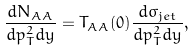Convert formula to latex. <formula><loc_0><loc_0><loc_500><loc_500>\frac { d N _ { A A } } { d p _ { T } ^ { 2 } d y } = T _ { A A } ( { 0 } ) \frac { d \sigma _ { j e t } } { d p _ { T } ^ { 2 } d y } ,</formula> 